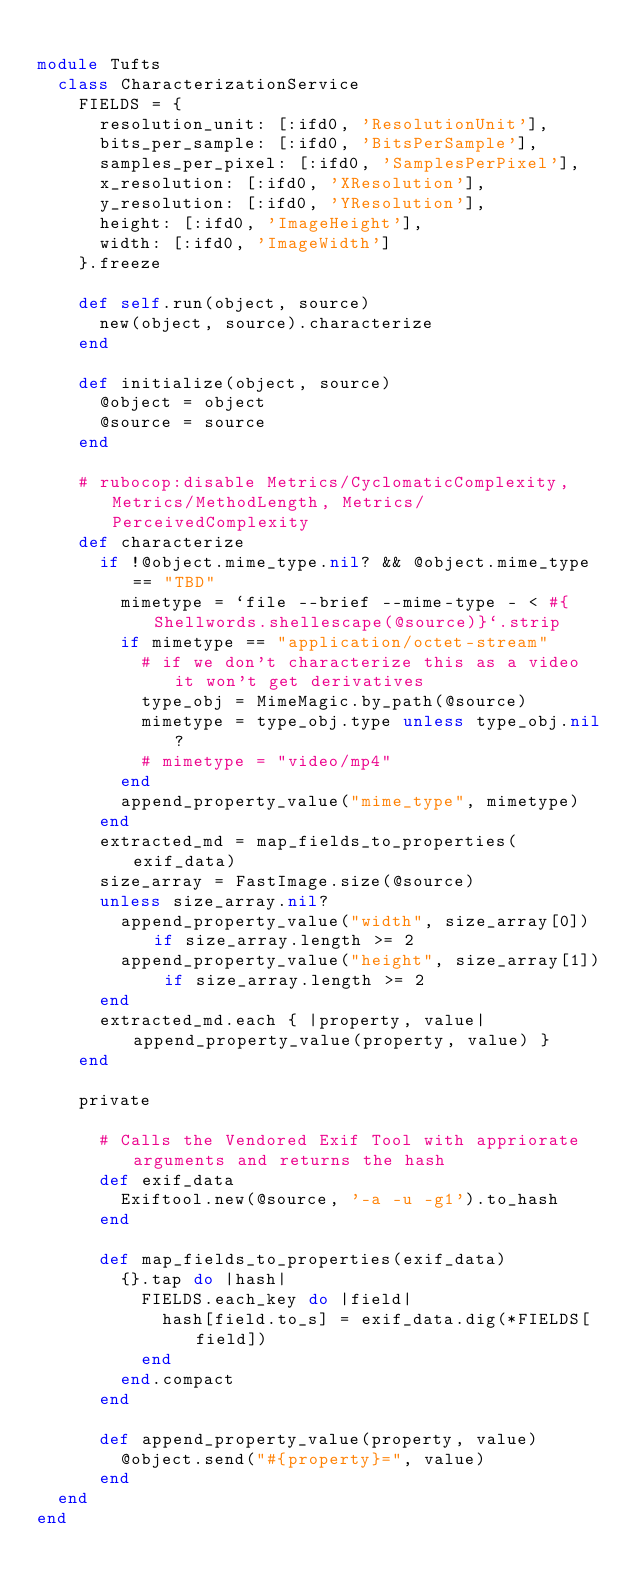Convert code to text. <code><loc_0><loc_0><loc_500><loc_500><_Ruby_>
module Tufts
  class CharacterizationService
    FIELDS = {
      resolution_unit: [:ifd0, 'ResolutionUnit'],
      bits_per_sample: [:ifd0, 'BitsPerSample'],
      samples_per_pixel: [:ifd0, 'SamplesPerPixel'],
      x_resolution: [:ifd0, 'XResolution'],
      y_resolution: [:ifd0, 'YResolution'],
      height: [:ifd0, 'ImageHeight'],
      width: [:ifd0, 'ImageWidth']
    }.freeze

    def self.run(object, source)
      new(object, source).characterize
    end

    def initialize(object, source)
      @object = object
      @source = source
    end

    # rubocop:disable Metrics/CyclomaticComplexity, Metrics/MethodLength, Metrics/PerceivedComplexity
    def characterize
      if !@object.mime_type.nil? && @object.mime_type == "TBD"
        mimetype = `file --brief --mime-type - < #{Shellwords.shellescape(@source)}`.strip
        if mimetype == "application/octet-stream"
          # if we don't characterize this as a video it won't get derivatives
          type_obj = MimeMagic.by_path(@source)
          mimetype = type_obj.type unless type_obj.nil?
          # mimetype = "video/mp4"
        end
        append_property_value("mime_type", mimetype)
      end
      extracted_md = map_fields_to_properties(exif_data)
      size_array = FastImage.size(@source)
      unless size_array.nil?
        append_property_value("width", size_array[0]) if size_array.length >= 2
        append_property_value("height", size_array[1]) if size_array.length >= 2
      end
      extracted_md.each { |property, value| append_property_value(property, value) }
    end

    private

      # Calls the Vendored Exif Tool with appriorate arguments and returns the hash
      def exif_data
        Exiftool.new(@source, '-a -u -g1').to_hash
      end

      def map_fields_to_properties(exif_data)
        {}.tap do |hash|
          FIELDS.each_key do |field|
            hash[field.to_s] = exif_data.dig(*FIELDS[field])
          end
        end.compact
      end

      def append_property_value(property, value)
        @object.send("#{property}=", value)
      end
  end
end
</code> 